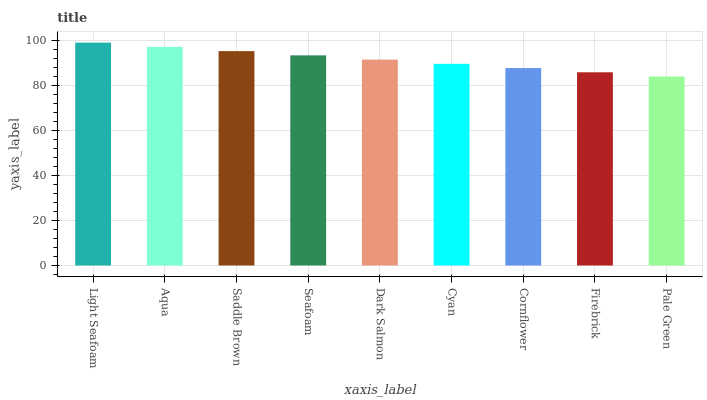Is Pale Green the minimum?
Answer yes or no. Yes. Is Light Seafoam the maximum?
Answer yes or no. Yes. Is Aqua the minimum?
Answer yes or no. No. Is Aqua the maximum?
Answer yes or no. No. Is Light Seafoam greater than Aqua?
Answer yes or no. Yes. Is Aqua less than Light Seafoam?
Answer yes or no. Yes. Is Aqua greater than Light Seafoam?
Answer yes or no. No. Is Light Seafoam less than Aqua?
Answer yes or no. No. Is Dark Salmon the high median?
Answer yes or no. Yes. Is Dark Salmon the low median?
Answer yes or no. Yes. Is Aqua the high median?
Answer yes or no. No. Is Saddle Brown the low median?
Answer yes or no. No. 